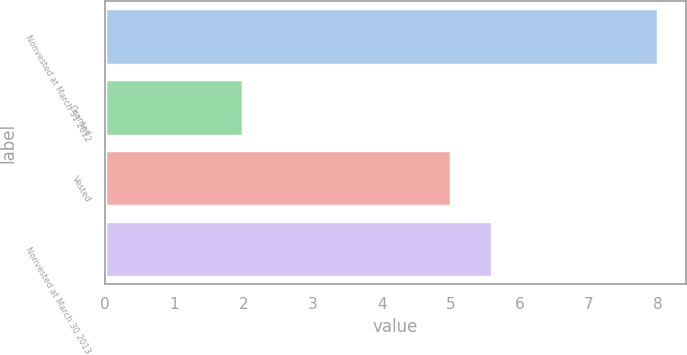Convert chart. <chart><loc_0><loc_0><loc_500><loc_500><bar_chart><fcel>Nonvested at March 31 2012<fcel>Granted<fcel>Vested<fcel>Nonvested at March 30 2013<nl><fcel>8<fcel>2<fcel>5<fcel>5.6<nl></chart> 